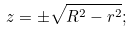Convert formula to latex. <formula><loc_0><loc_0><loc_500><loc_500>z = \pm \sqrt { R ^ { 2 } - r ^ { 2 } } ;</formula> 